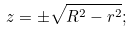Convert formula to latex. <formula><loc_0><loc_0><loc_500><loc_500>z = \pm \sqrt { R ^ { 2 } - r ^ { 2 } } ;</formula> 